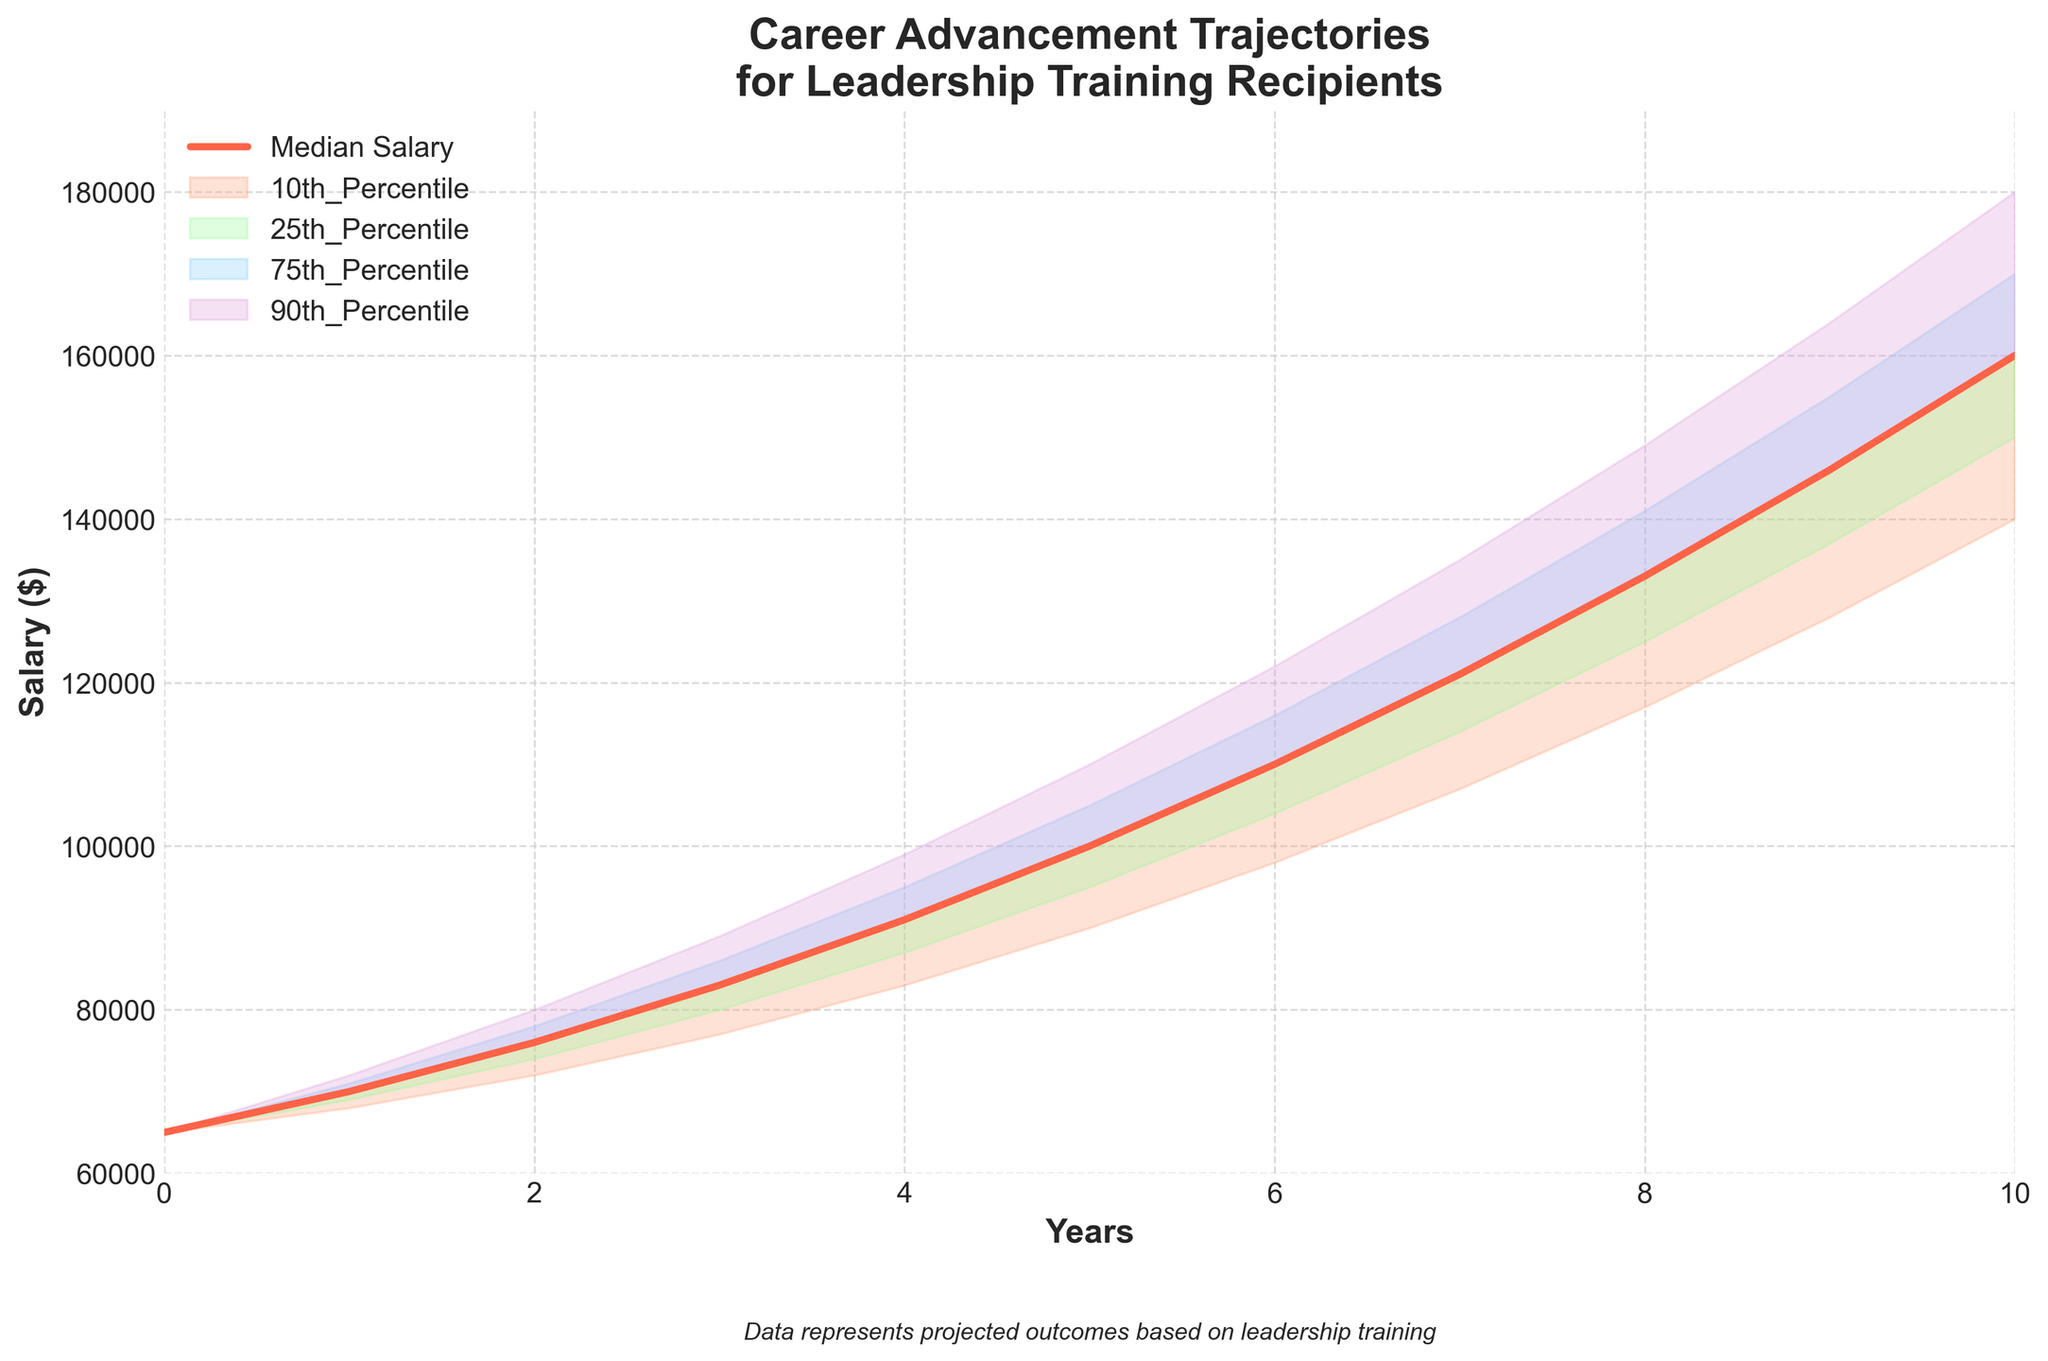What is the title of the plot? The title is usually displayed at the top of the plot. It summarizes what the figure is about.
Answer: Career Advancement Trajectories for Leadership Training Recipients What is the median salary in Year 5? Find the point on the median salary line corresponding to Year 5 on the x-axis. From the data, the median salary in Year 5 is given as $100,000.
Answer: $100,000 What are the salary ranges represented by the shaded areas? The shaded areas represent the salary percentiles. The lower shaded areas show the difference between the 10th and median, and the 25th and median, while the higher shaded areas show the difference between the 75th and median, and the 90th and median.
Answer: 10th, 25th, 75th, 90th Percentiles How does the median salary change from Year 0 to Year 10? Look at the median salary line and compare its value at Year 0 and Year 10. Initially, the median salary is $65,000. In Year 10, it is $160,000. To find the change, subtract the initial value from the final value. So, $160,000 - $65,000 = $95,000.
Answer: The median salary increases by $95,000 In which year does the 10th percentile salary first exceed $100,000? Identify the 10th percentile line and see where it first crosses above $100,000 on the y-axis. This occurs in Year 6.
Answer: Year 6 How much higher is the 90th percentile salary than the 10th percentile salary in Year 10? For Year 10, the 90th percentile salary is $180,000 and the 10th percentile salary is $140,000. Calculate the difference: $180,000 - $140,000 = $40,000.
Answer: $40,000 Which percentile shows the most significant increase from Year 0 to Year 10, and by how much? Calculate the increase for each percentile by subtracting the initial value at Year 0 from the value at Year 10. The changes are:
- 10th: $140,000 - $65,000 = $75,000
- 25th: $150,000 - $65,000 = $85,000
- 75th: $170,000 - $65,000 = $105,000
- 90th: $180,000 - $65,000 = $115,000
The 90th percentile shows the most significant increase.
Answer: 90th percentile, $115,000 What is the salary range for Year 3, and what does it represent? Find the minimum and maximum values for Year 3. From the data, the 10th percentile is $77,000, and the 90th percentile is $89,000. The salary range is the difference between these values: $89,000 - $77,000 = $12,000. This range represents the spread of salaries from the lowest 10% to the highest 10%.
Answer: $77,000 to $89,000, representing the 10th to 90th percentile range 